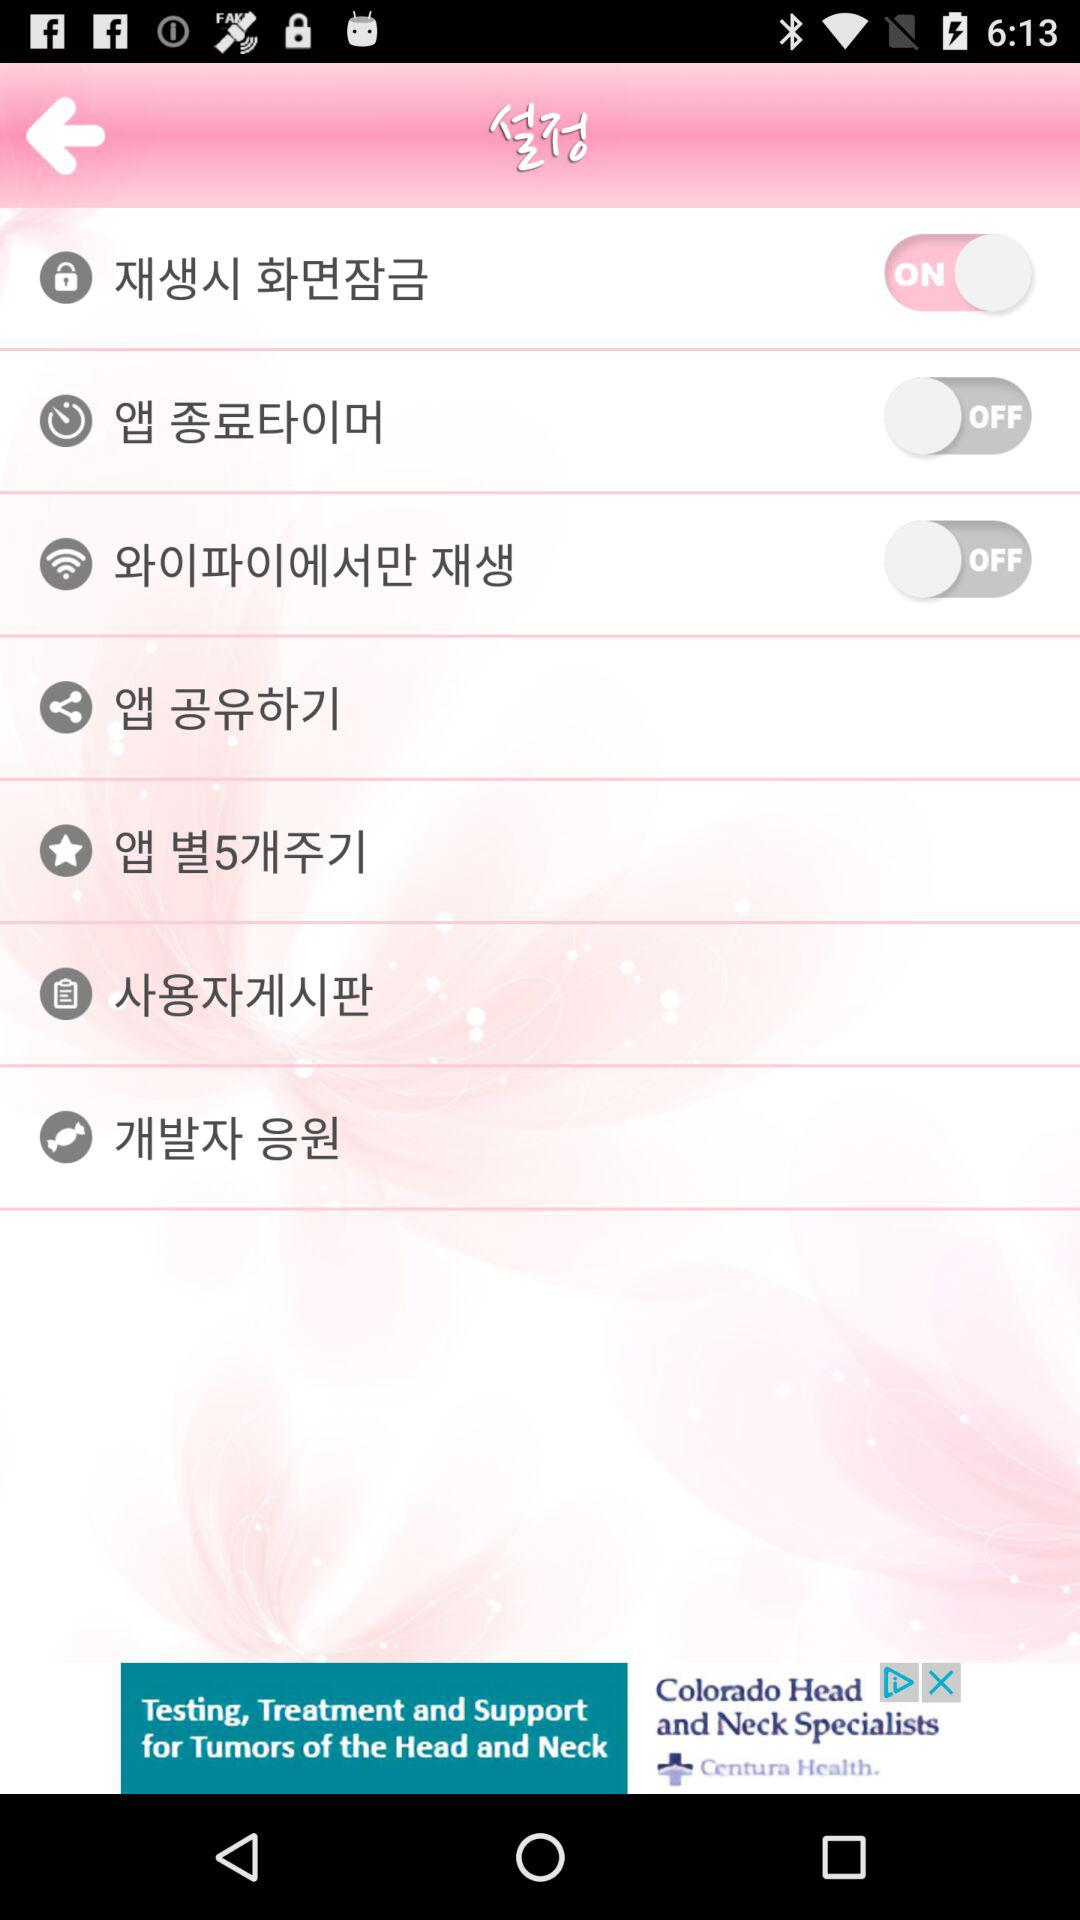How many items have a switch?
Answer the question using a single word or phrase. 3 